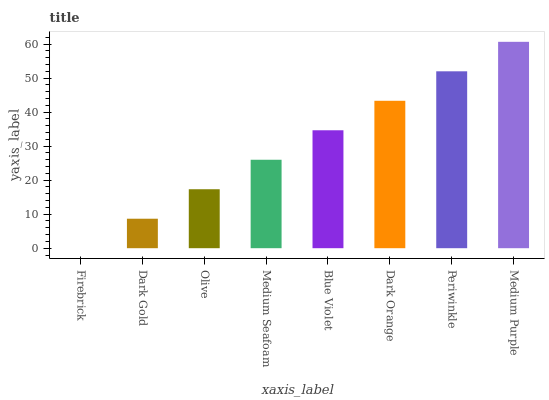Is Firebrick the minimum?
Answer yes or no. Yes. Is Medium Purple the maximum?
Answer yes or no. Yes. Is Dark Gold the minimum?
Answer yes or no. No. Is Dark Gold the maximum?
Answer yes or no. No. Is Dark Gold greater than Firebrick?
Answer yes or no. Yes. Is Firebrick less than Dark Gold?
Answer yes or no. Yes. Is Firebrick greater than Dark Gold?
Answer yes or no. No. Is Dark Gold less than Firebrick?
Answer yes or no. No. Is Blue Violet the high median?
Answer yes or no. Yes. Is Medium Seafoam the low median?
Answer yes or no. Yes. Is Dark Orange the high median?
Answer yes or no. No. Is Firebrick the low median?
Answer yes or no. No. 